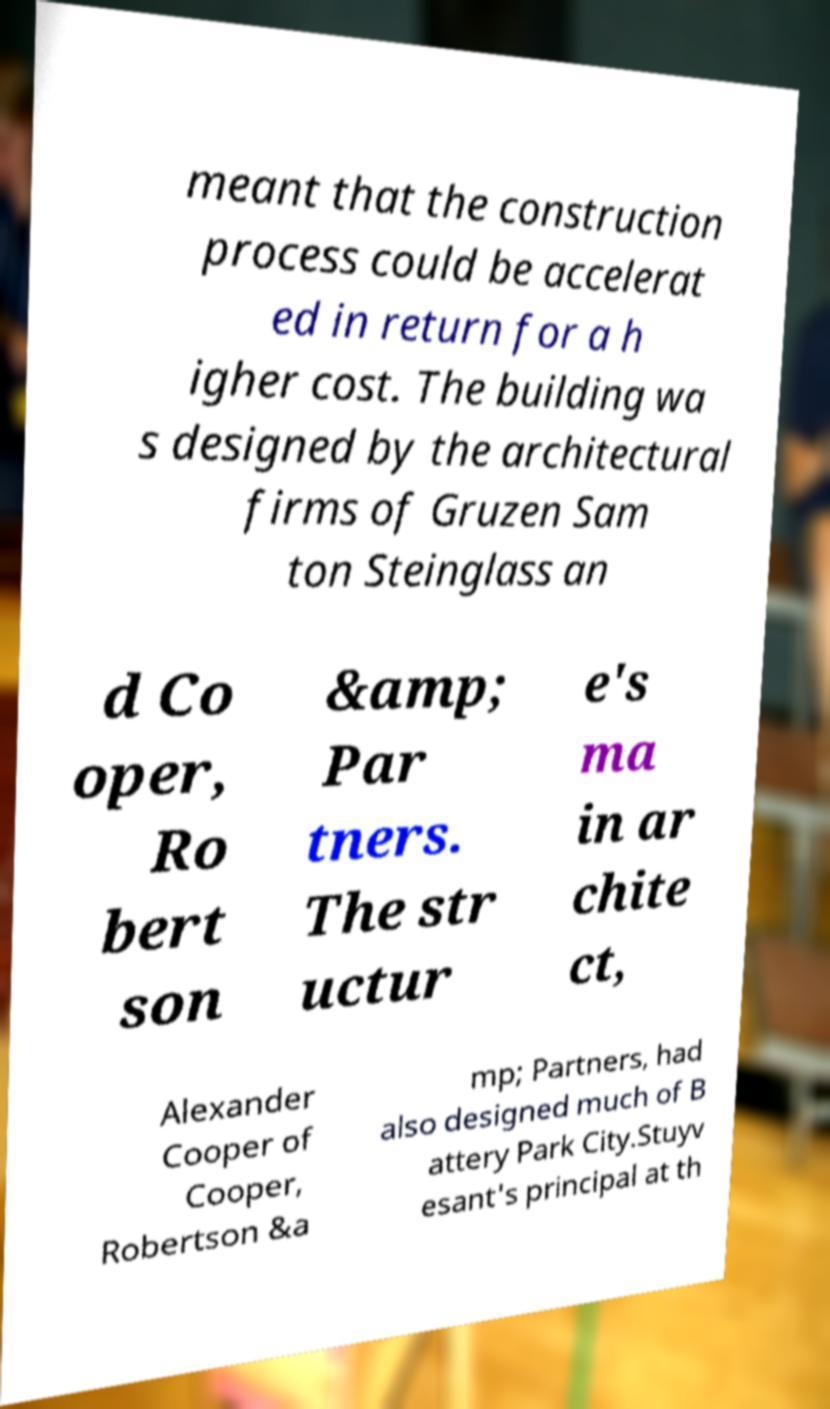What messages or text are displayed in this image? I need them in a readable, typed format. meant that the construction process could be accelerat ed in return for a h igher cost. The building wa s designed by the architectural firms of Gruzen Sam ton Steinglass an d Co oper, Ro bert son &amp; Par tners. The str uctur e's ma in ar chite ct, Alexander Cooper of Cooper, Robertson &a mp; Partners, had also designed much of B attery Park City.Stuyv esant's principal at th 